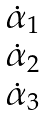Convert formula to latex. <formula><loc_0><loc_0><loc_500><loc_500>\begin{matrix} \dot { \alpha } _ { 1 } \\ \dot { \alpha } _ { 2 } \\ \dot { \alpha } _ { 3 } \end{matrix}</formula> 